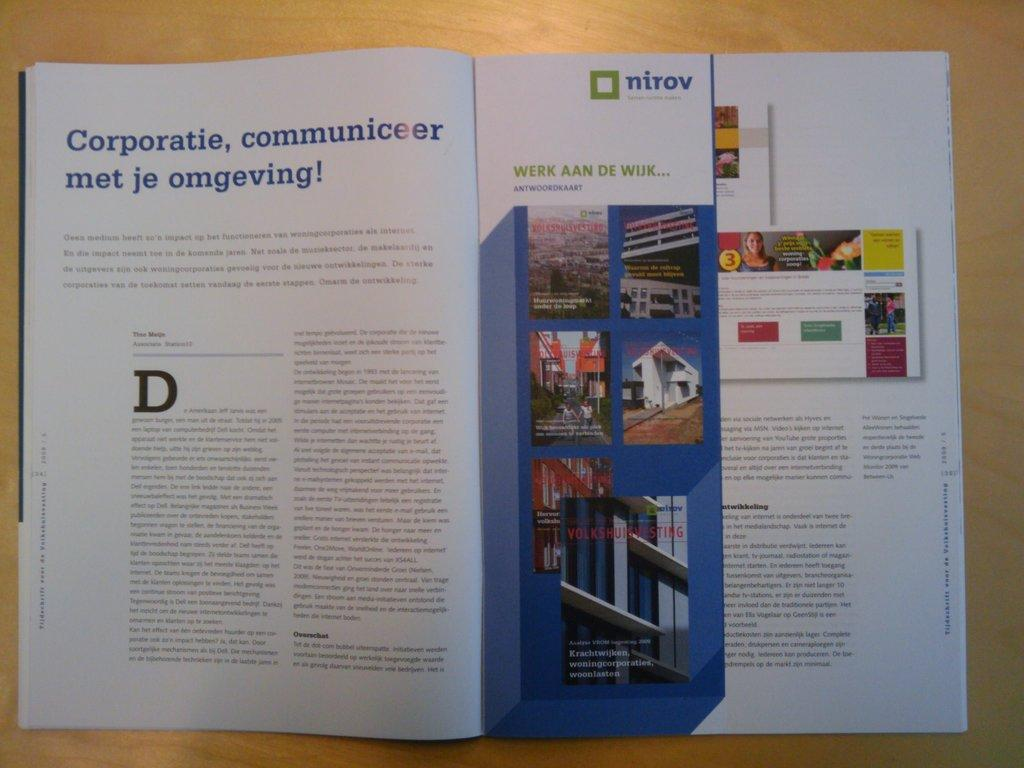<image>
Write a terse but informative summary of the picture. A magazine ad is associated with a company named Nirov. 